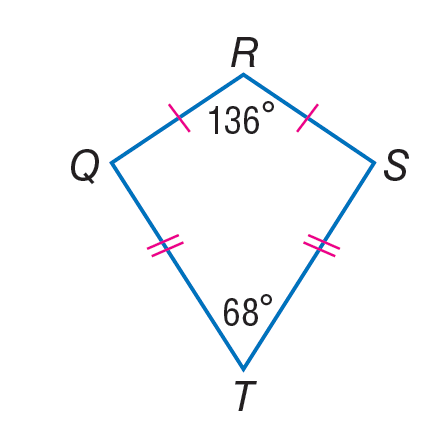Answer the mathemtical geometry problem and directly provide the correct option letter.
Question: If Q R S T is a kite, find m \angle R S T.
Choices: A: 39 B: 68 C: 78 D: 136 C 